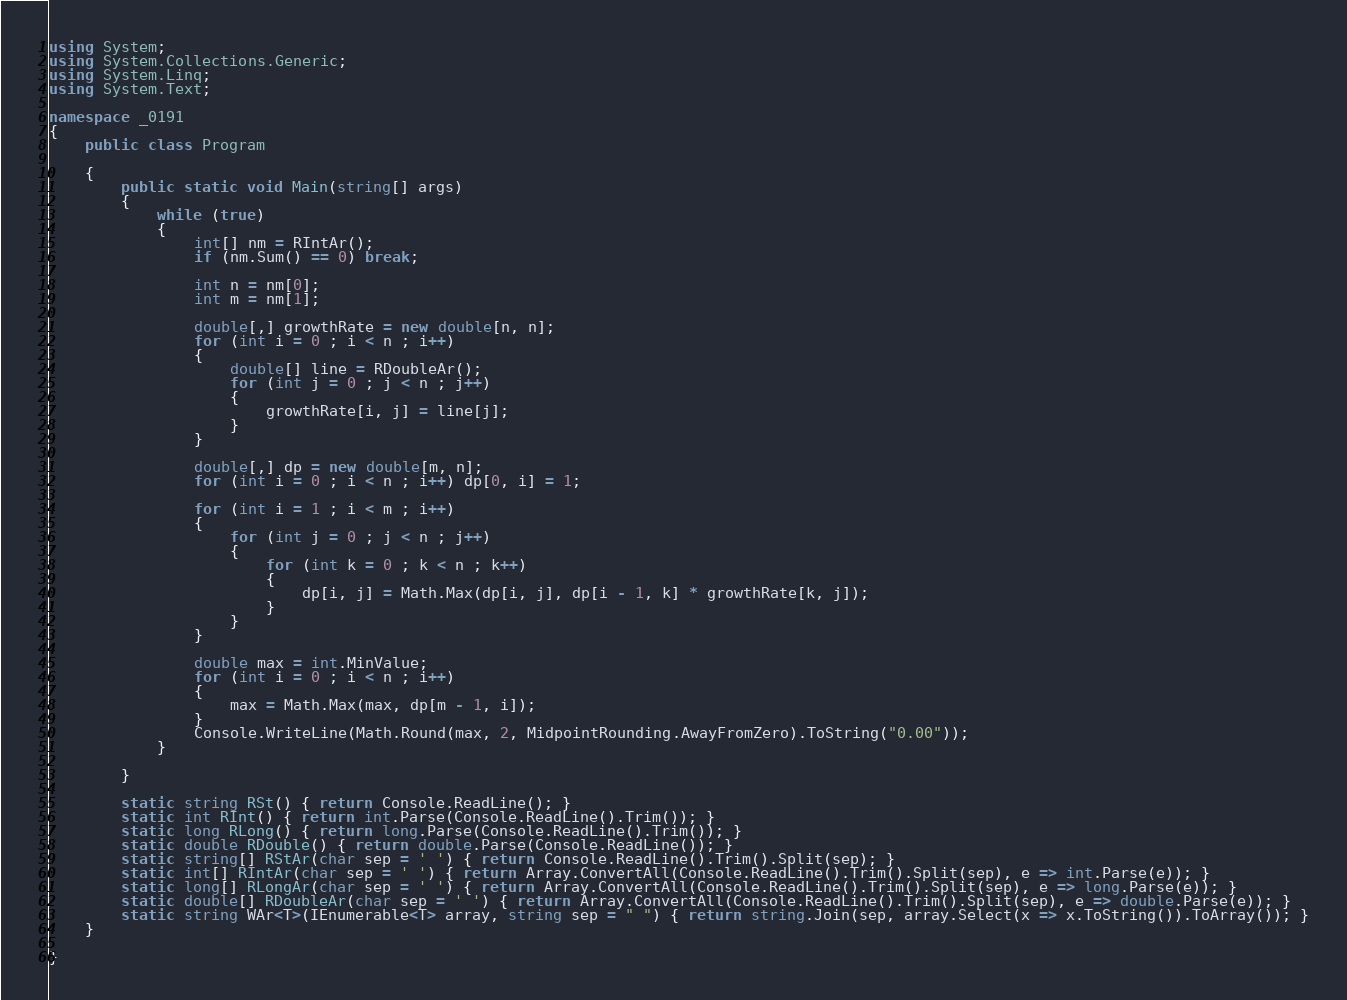Convert code to text. <code><loc_0><loc_0><loc_500><loc_500><_C#_>using System;
using System.Collections.Generic;
using System.Linq;
using System.Text;

namespace _0191
{
    public class Program

    {
        public static void Main(string[] args)
        {
            while (true)
            {
                int[] nm = RIntAr();
                if (nm.Sum() == 0) break;

                int n = nm[0];
                int m = nm[1];

                double[,] growthRate = new double[n, n];
                for (int i = 0 ; i < n ; i++)
                {
                    double[] line = RDoubleAr();
                    for (int j = 0 ; j < n ; j++)
                    {
                        growthRate[i, j] = line[j];
                    }
                }

                double[,] dp = new double[m, n];
                for (int i = 0 ; i < n ; i++) dp[0, i] = 1;

                for (int i = 1 ; i < m ; i++)
                {
                    for (int j = 0 ; j < n ; j++)
                    {
                        for (int k = 0 ; k < n ; k++)
                        {
                            dp[i, j] = Math.Max(dp[i, j], dp[i - 1, k] * growthRate[k, j]);
                        }
                    }
                }

                double max = int.MinValue;
                for (int i = 0 ; i < n ; i++)
                {
                    max = Math.Max(max, dp[m - 1, i]);
                }
                Console.WriteLine(Math.Round(max, 2, MidpointRounding.AwayFromZero).ToString("0.00"));
            }

        }

        static string RSt() { return Console.ReadLine(); }
        static int RInt() { return int.Parse(Console.ReadLine().Trim()); }
        static long RLong() { return long.Parse(Console.ReadLine().Trim()); }
        static double RDouble() { return double.Parse(Console.ReadLine()); }
        static string[] RStAr(char sep = ' ') { return Console.ReadLine().Trim().Split(sep); }
        static int[] RIntAr(char sep = ' ') { return Array.ConvertAll(Console.ReadLine().Trim().Split(sep), e => int.Parse(e)); }
        static long[] RLongAr(char sep = ' ') { return Array.ConvertAll(Console.ReadLine().Trim().Split(sep), e => long.Parse(e)); }
        static double[] RDoubleAr(char sep = ' ') { return Array.ConvertAll(Console.ReadLine().Trim().Split(sep), e => double.Parse(e)); }
        static string WAr<T>(IEnumerable<T> array, string sep = " ") { return string.Join(sep, array.Select(x => x.ToString()).ToArray()); }
    }

}

</code> 